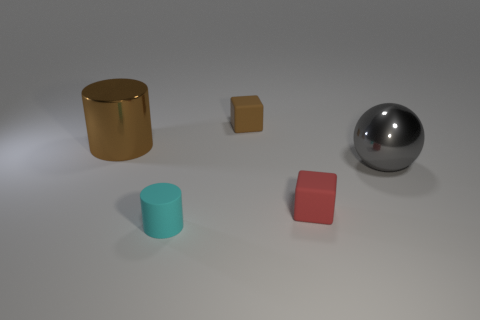Does the gray thing have the same material as the brown cylinder?
Offer a very short reply. Yes. What is the shape of the thing that is the same color as the big shiny cylinder?
Your answer should be very brief. Cube. There is a tiny block in front of the brown matte cube; is its color the same as the matte cylinder?
Your response must be concise. No. How many cylinders are to the right of the cylinder in front of the large gray metal object?
Offer a terse response. 0. There is a thing that is the same size as the shiny cylinder; what is its color?
Make the answer very short. Gray. What is the object that is on the left side of the rubber cylinder made of?
Give a very brief answer. Metal. What is the material of the object that is both to the right of the tiny brown rubber block and to the left of the ball?
Offer a terse response. Rubber. There is a brown rubber object that is behind the cyan cylinder; does it have the same size as the red cube?
Offer a terse response. Yes. What is the shape of the large brown object?
Your answer should be very brief. Cylinder. What number of large red metallic objects have the same shape as the cyan thing?
Provide a short and direct response. 0. 